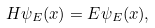Convert formula to latex. <formula><loc_0><loc_0><loc_500><loc_500>H \psi _ { E } ( { x } ) = E \psi _ { E } ( { x } ) ,</formula> 